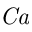<formula> <loc_0><loc_0><loc_500><loc_500>C a</formula> 